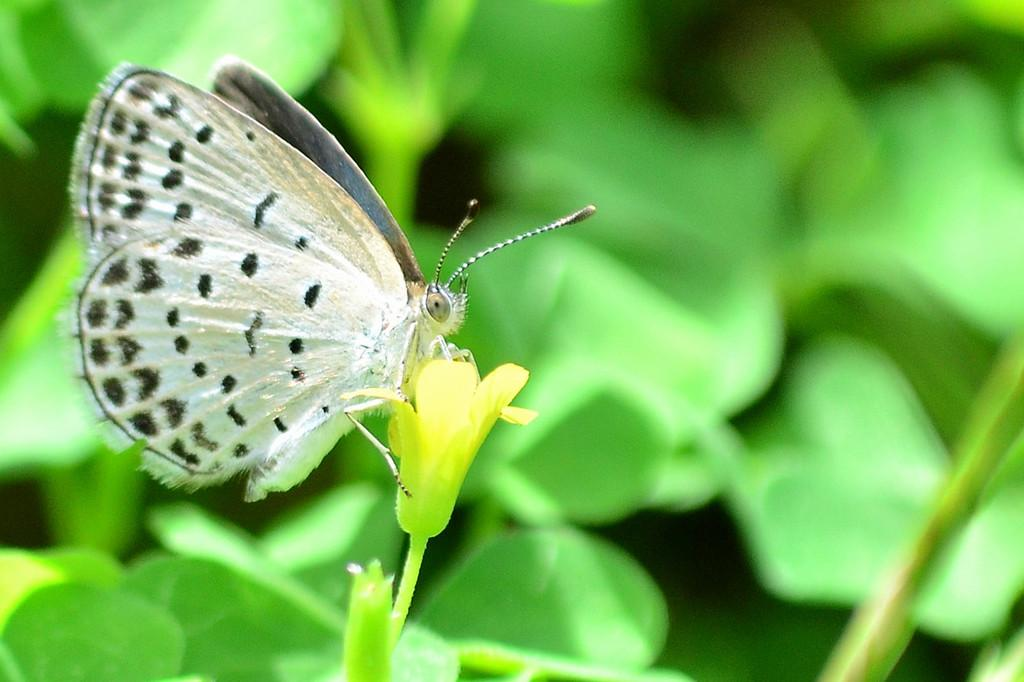What is the main subject of the image? There is a butterfly in the image. Where is the butterfly located? The butterfly is on a flower. What color is the background of the image? The background of the image is green. What type of gun is the butterfly holding in the image? There is no gun present in the image; it features a butterfly on a flower. Can you describe the smile on the butterfly's face in the image? Butterflies do not have facial expressions, so there is no smile on the butterfly's face in the image. 